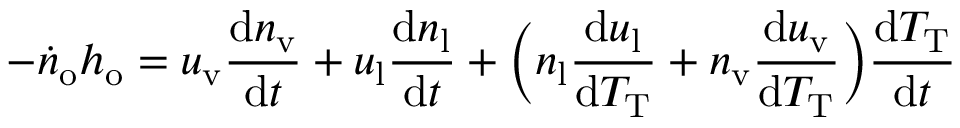Convert formula to latex. <formula><loc_0><loc_0><loc_500><loc_500>- \dot { n } _ { o } h _ { o } = u _ { v } \frac { d n _ { v } } { d t } + u _ { l } \frac { d n _ { l } } { d t } + \left ( n _ { l } \frac { d u _ { l } } { d T _ { T } } + n _ { v } \frac { d u _ { v } } { d T _ { T } } \right ) \frac { d T _ { T } } { d t }</formula> 